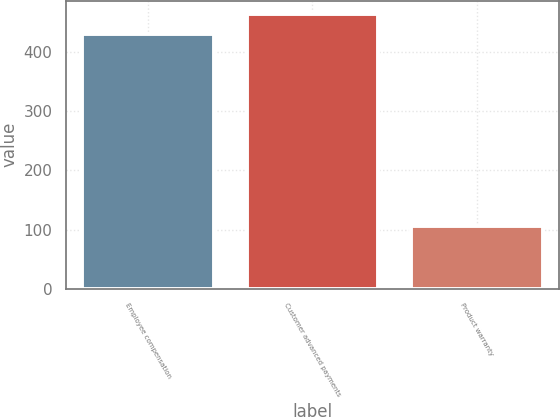Convert chart. <chart><loc_0><loc_0><loc_500><loc_500><bar_chart><fcel>Employee compensation<fcel>Customer advanced payments<fcel>Product warranty<nl><fcel>431<fcel>463.7<fcel>106<nl></chart> 